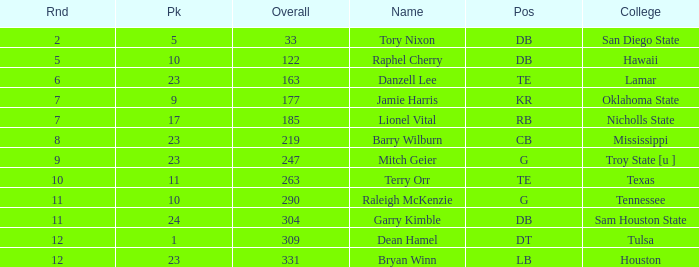Which Overall is the highest one that has a Name of raleigh mckenzie, and a Pick larger than 10? None. 